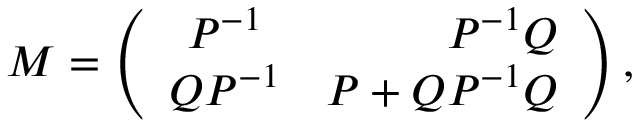<formula> <loc_0><loc_0><loc_500><loc_500>M = \left ( \begin{array} { c r c } { { P ^ { - 1 } } } & { { P ^ { - 1 } Q } } \\ { { Q P ^ { - 1 } } } & { { P + Q P ^ { - 1 } Q } } \end{array} \right ) ,</formula> 